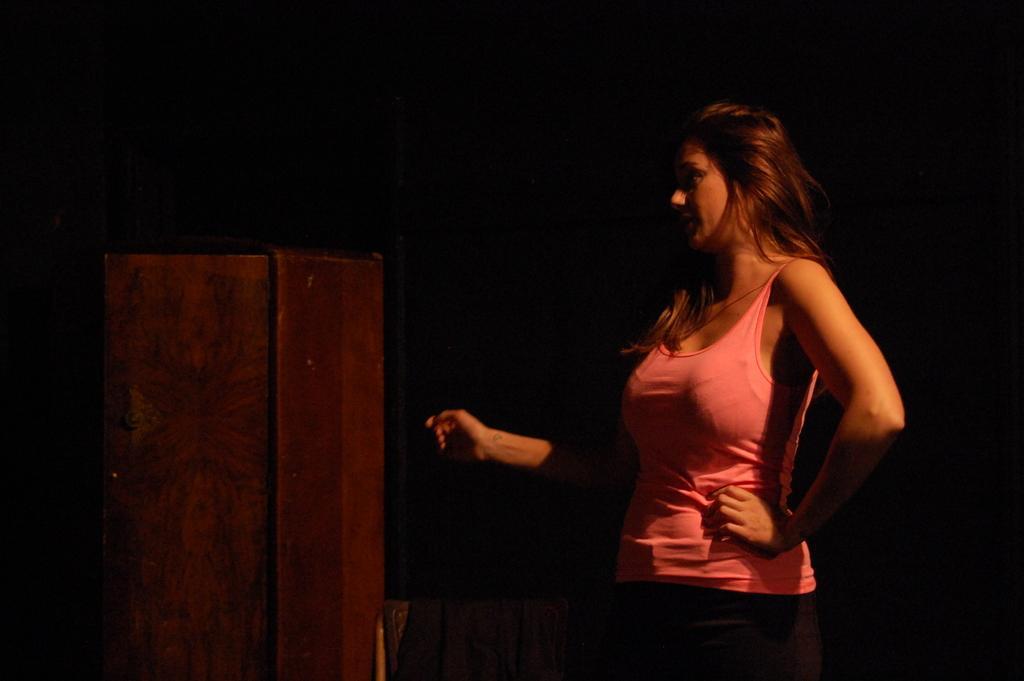How would you summarize this image in a sentence or two? This image consists of a woman wearing a pink top. On the left, we can see a wooden cabinet. The background is too dark. 